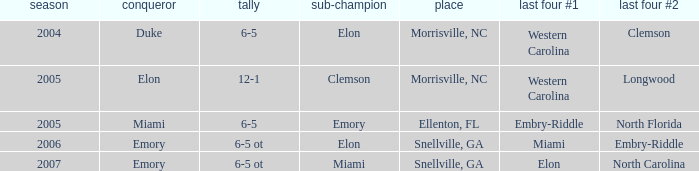Where was the final game played in 2007 Snellville, GA. 